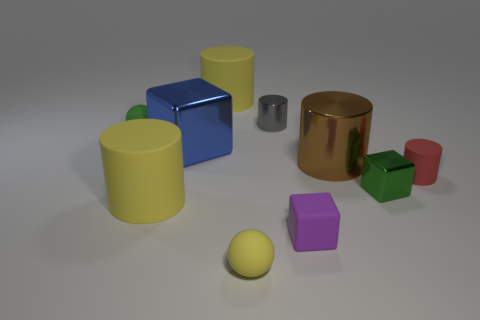Are there more big yellow things that are in front of the purple object than tiny green rubber balls left of the blue thing?
Give a very brief answer. No. There is a thing that is the same color as the tiny shiny cube; what is its size?
Make the answer very short. Small. Does the gray cylinder have the same size as the green object that is left of the gray cylinder?
Your answer should be very brief. Yes. How many cubes are either small yellow rubber things or small red things?
Provide a succinct answer. 0. The other cylinder that is the same material as the small gray cylinder is what size?
Offer a very short reply. Large. Do the rubber sphere that is behind the tiny red matte thing and the yellow thing behind the brown thing have the same size?
Your answer should be compact. No. What number of things are red matte things or rubber cylinders?
Ensure brevity in your answer.  3. What is the shape of the small purple rubber thing?
Offer a very short reply. Cube. There is another thing that is the same shape as the green rubber object; what is its size?
Your response must be concise. Small. Is there anything else that has the same material as the brown thing?
Your answer should be very brief. Yes. 